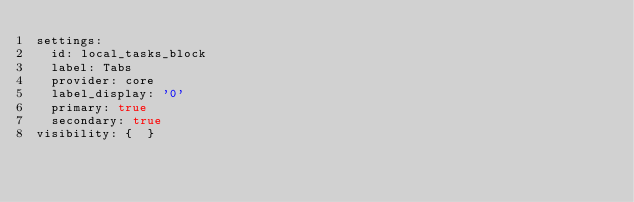<code> <loc_0><loc_0><loc_500><loc_500><_YAML_>settings:
  id: local_tasks_block
  label: Tabs
  provider: core
  label_display: '0'
  primary: true
  secondary: true
visibility: {  }
</code> 